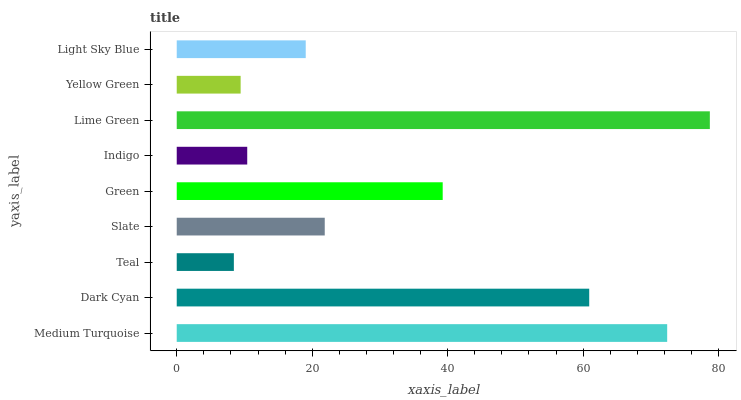Is Teal the minimum?
Answer yes or no. Yes. Is Lime Green the maximum?
Answer yes or no. Yes. Is Dark Cyan the minimum?
Answer yes or no. No. Is Dark Cyan the maximum?
Answer yes or no. No. Is Medium Turquoise greater than Dark Cyan?
Answer yes or no. Yes. Is Dark Cyan less than Medium Turquoise?
Answer yes or no. Yes. Is Dark Cyan greater than Medium Turquoise?
Answer yes or no. No. Is Medium Turquoise less than Dark Cyan?
Answer yes or no. No. Is Slate the high median?
Answer yes or no. Yes. Is Slate the low median?
Answer yes or no. Yes. Is Teal the high median?
Answer yes or no. No. Is Yellow Green the low median?
Answer yes or no. No. 